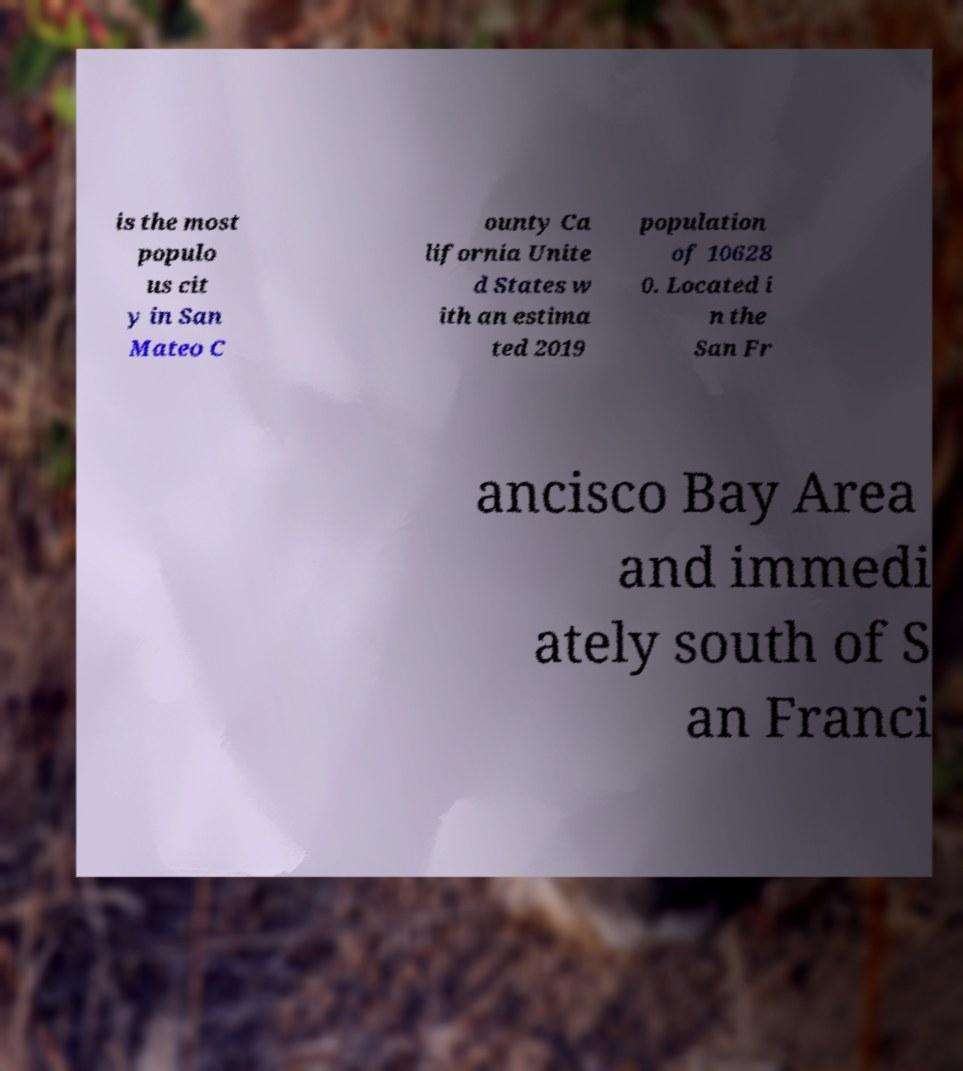For documentation purposes, I need the text within this image transcribed. Could you provide that? is the most populo us cit y in San Mateo C ounty Ca lifornia Unite d States w ith an estima ted 2019 population of 10628 0. Located i n the San Fr ancisco Bay Area and immedi ately south of S an Franci 